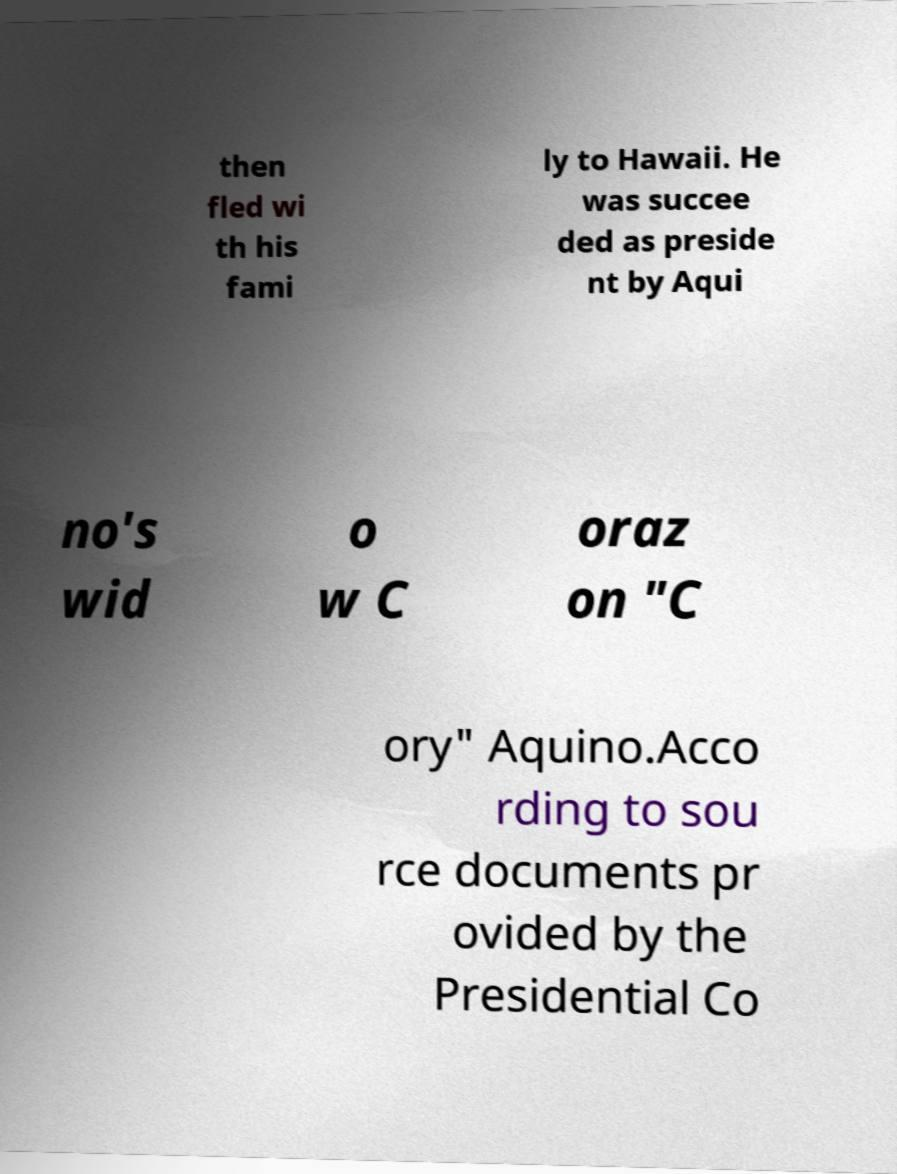Could you assist in decoding the text presented in this image and type it out clearly? then fled wi th his fami ly to Hawaii. He was succee ded as preside nt by Aqui no's wid o w C oraz on "C ory" Aquino.Acco rding to sou rce documents pr ovided by the Presidential Co 